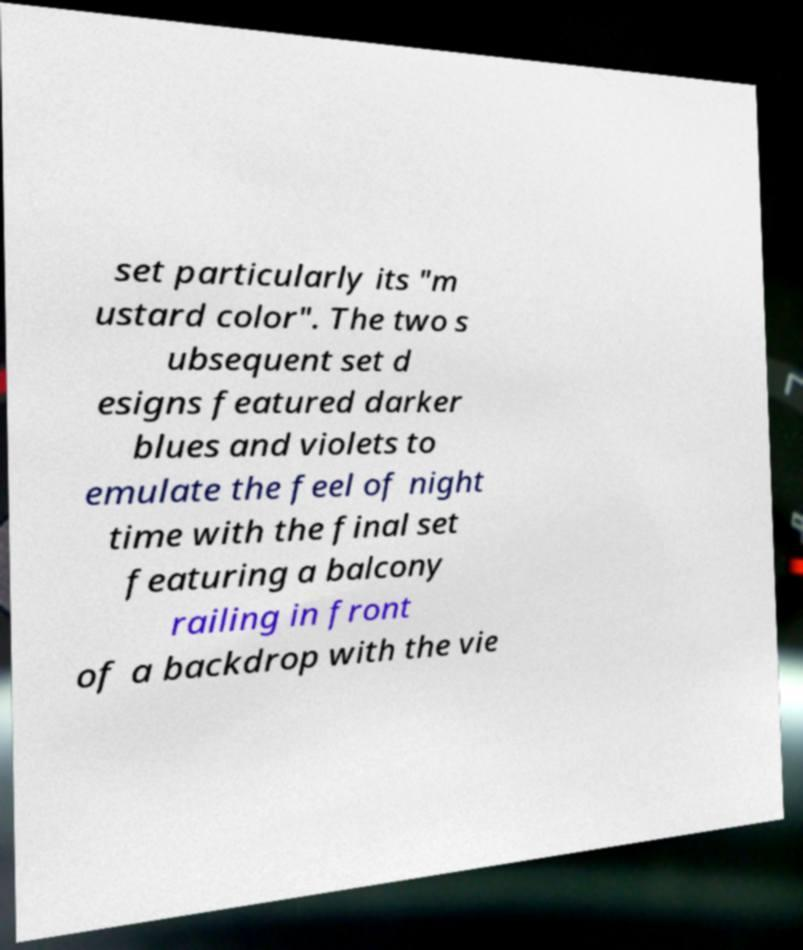There's text embedded in this image that I need extracted. Can you transcribe it verbatim? set particularly its "m ustard color". The two s ubsequent set d esigns featured darker blues and violets to emulate the feel of night time with the final set featuring a balcony railing in front of a backdrop with the vie 